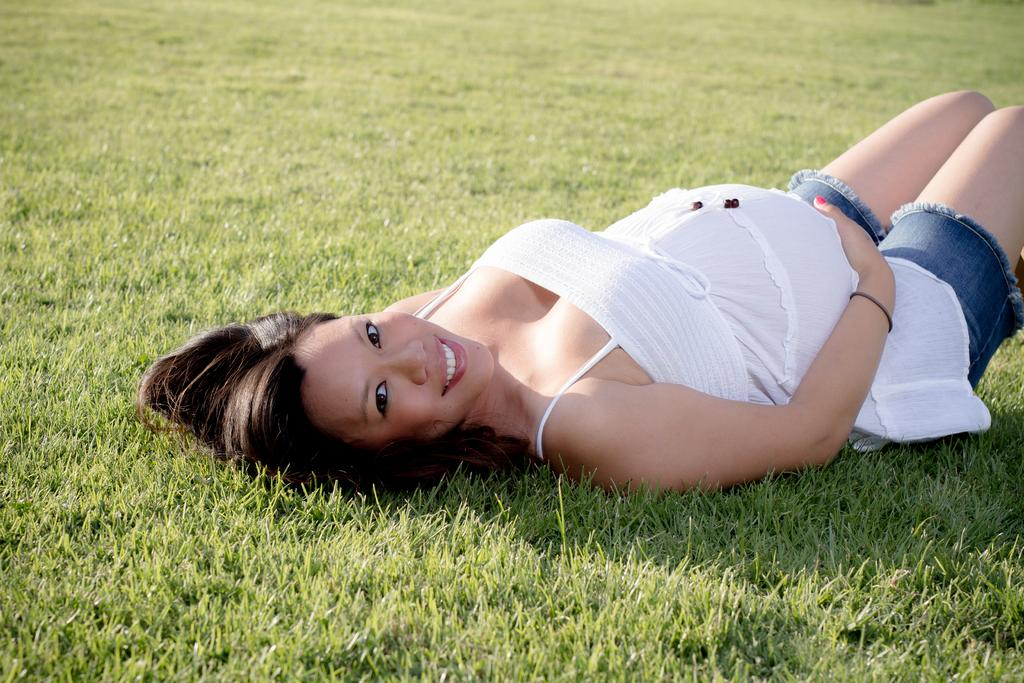Who is present in the image? There is a woman in the image. What is the woman doing in the image? The woman is lying down. What expression does the woman have in the image? The woman is smiling. What can be seen in the background of the image? There is grass visible in the background of the image. What type of powder is being used by the trucks in the image? There are no trucks present in the image, so there is no powder being used. 